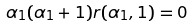<formula> <loc_0><loc_0><loc_500><loc_500>\alpha _ { 1 } ( \alpha _ { 1 } + 1 ) r ( \alpha _ { 1 } , 1 ) = 0</formula> 